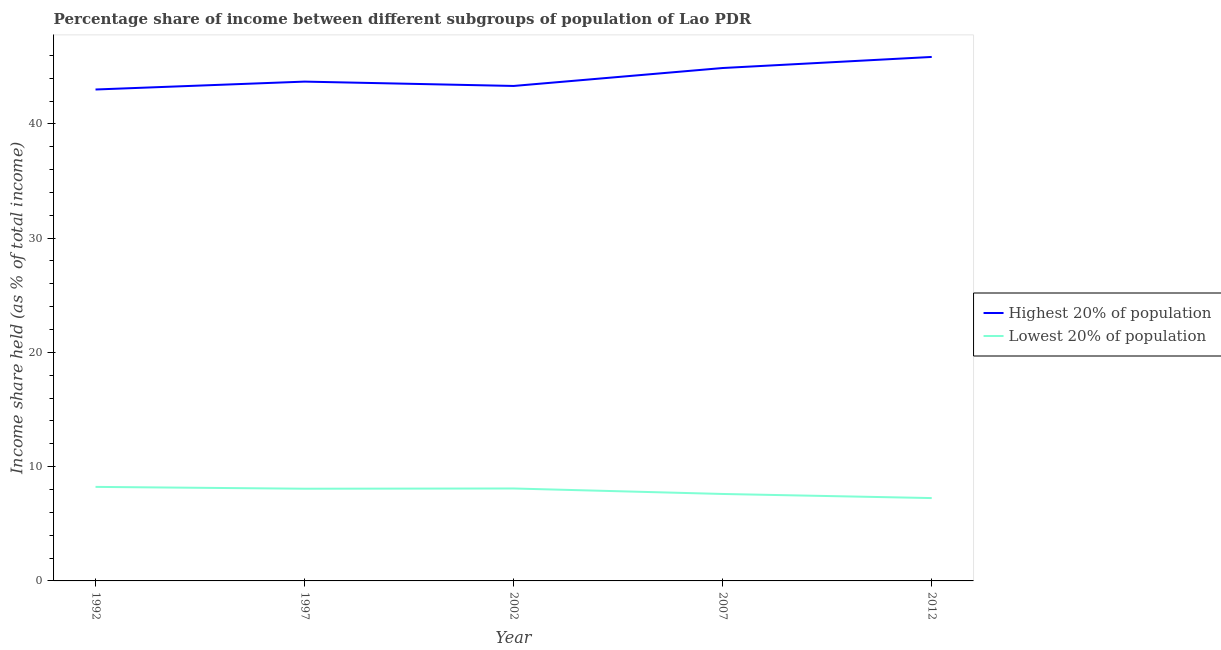How many different coloured lines are there?
Your answer should be compact. 2. What is the income share held by lowest 20% of the population in 2007?
Your response must be concise. 7.61. Across all years, what is the maximum income share held by highest 20% of the population?
Ensure brevity in your answer.  45.86. Across all years, what is the minimum income share held by highest 20% of the population?
Your answer should be compact. 43.01. In which year was the income share held by lowest 20% of the population maximum?
Your answer should be very brief. 1992. In which year was the income share held by highest 20% of the population minimum?
Provide a short and direct response. 1992. What is the total income share held by highest 20% of the population in the graph?
Offer a very short reply. 220.78. What is the difference between the income share held by lowest 20% of the population in 2002 and that in 2007?
Your response must be concise. 0.48. What is the difference between the income share held by highest 20% of the population in 2012 and the income share held by lowest 20% of the population in 1992?
Provide a short and direct response. 37.63. What is the average income share held by lowest 20% of the population per year?
Provide a succinct answer. 7.85. In the year 2007, what is the difference between the income share held by lowest 20% of the population and income share held by highest 20% of the population?
Your response must be concise. -37.28. What is the ratio of the income share held by lowest 20% of the population in 1997 to that in 2012?
Ensure brevity in your answer.  1.11. What is the difference between the highest and the second highest income share held by highest 20% of the population?
Your answer should be very brief. 0.97. What is the difference between the highest and the lowest income share held by highest 20% of the population?
Your response must be concise. 2.85. Is the sum of the income share held by lowest 20% of the population in 2007 and 2012 greater than the maximum income share held by highest 20% of the population across all years?
Ensure brevity in your answer.  No. Does the income share held by lowest 20% of the population monotonically increase over the years?
Your answer should be very brief. No. Is the income share held by lowest 20% of the population strictly greater than the income share held by highest 20% of the population over the years?
Provide a succinct answer. No. How many years are there in the graph?
Ensure brevity in your answer.  5. What is the difference between two consecutive major ticks on the Y-axis?
Your answer should be compact. 10. Are the values on the major ticks of Y-axis written in scientific E-notation?
Ensure brevity in your answer.  No. Does the graph contain any zero values?
Your answer should be very brief. No. Does the graph contain grids?
Ensure brevity in your answer.  No. Where does the legend appear in the graph?
Provide a short and direct response. Center right. How many legend labels are there?
Your response must be concise. 2. How are the legend labels stacked?
Your answer should be compact. Vertical. What is the title of the graph?
Provide a succinct answer. Percentage share of income between different subgroups of population of Lao PDR. What is the label or title of the Y-axis?
Your response must be concise. Income share held (as % of total income). What is the Income share held (as % of total income) in Highest 20% of population in 1992?
Your response must be concise. 43.01. What is the Income share held (as % of total income) of Lowest 20% of population in 1992?
Offer a very short reply. 8.23. What is the Income share held (as % of total income) in Highest 20% of population in 1997?
Offer a very short reply. 43.7. What is the Income share held (as % of total income) in Lowest 20% of population in 1997?
Make the answer very short. 8.07. What is the Income share held (as % of total income) of Highest 20% of population in 2002?
Make the answer very short. 43.32. What is the Income share held (as % of total income) of Lowest 20% of population in 2002?
Your answer should be compact. 8.09. What is the Income share held (as % of total income) in Highest 20% of population in 2007?
Provide a succinct answer. 44.89. What is the Income share held (as % of total income) in Lowest 20% of population in 2007?
Your response must be concise. 7.61. What is the Income share held (as % of total income) in Highest 20% of population in 2012?
Offer a terse response. 45.86. What is the Income share held (as % of total income) in Lowest 20% of population in 2012?
Offer a very short reply. 7.25. Across all years, what is the maximum Income share held (as % of total income) in Highest 20% of population?
Give a very brief answer. 45.86. Across all years, what is the maximum Income share held (as % of total income) in Lowest 20% of population?
Your response must be concise. 8.23. Across all years, what is the minimum Income share held (as % of total income) of Highest 20% of population?
Offer a terse response. 43.01. Across all years, what is the minimum Income share held (as % of total income) in Lowest 20% of population?
Provide a succinct answer. 7.25. What is the total Income share held (as % of total income) of Highest 20% of population in the graph?
Offer a terse response. 220.78. What is the total Income share held (as % of total income) in Lowest 20% of population in the graph?
Provide a succinct answer. 39.25. What is the difference between the Income share held (as % of total income) in Highest 20% of population in 1992 and that in 1997?
Provide a short and direct response. -0.69. What is the difference between the Income share held (as % of total income) in Lowest 20% of population in 1992 and that in 1997?
Offer a very short reply. 0.16. What is the difference between the Income share held (as % of total income) of Highest 20% of population in 1992 and that in 2002?
Your answer should be compact. -0.31. What is the difference between the Income share held (as % of total income) of Lowest 20% of population in 1992 and that in 2002?
Offer a very short reply. 0.14. What is the difference between the Income share held (as % of total income) of Highest 20% of population in 1992 and that in 2007?
Offer a very short reply. -1.88. What is the difference between the Income share held (as % of total income) in Lowest 20% of population in 1992 and that in 2007?
Provide a succinct answer. 0.62. What is the difference between the Income share held (as % of total income) in Highest 20% of population in 1992 and that in 2012?
Give a very brief answer. -2.85. What is the difference between the Income share held (as % of total income) of Lowest 20% of population in 1992 and that in 2012?
Make the answer very short. 0.98. What is the difference between the Income share held (as % of total income) of Highest 20% of population in 1997 and that in 2002?
Ensure brevity in your answer.  0.38. What is the difference between the Income share held (as % of total income) of Lowest 20% of population in 1997 and that in 2002?
Provide a short and direct response. -0.02. What is the difference between the Income share held (as % of total income) in Highest 20% of population in 1997 and that in 2007?
Give a very brief answer. -1.19. What is the difference between the Income share held (as % of total income) of Lowest 20% of population in 1997 and that in 2007?
Your response must be concise. 0.46. What is the difference between the Income share held (as % of total income) of Highest 20% of population in 1997 and that in 2012?
Your response must be concise. -2.16. What is the difference between the Income share held (as % of total income) of Lowest 20% of population in 1997 and that in 2012?
Give a very brief answer. 0.82. What is the difference between the Income share held (as % of total income) of Highest 20% of population in 2002 and that in 2007?
Offer a very short reply. -1.57. What is the difference between the Income share held (as % of total income) of Lowest 20% of population in 2002 and that in 2007?
Offer a very short reply. 0.48. What is the difference between the Income share held (as % of total income) of Highest 20% of population in 2002 and that in 2012?
Your answer should be compact. -2.54. What is the difference between the Income share held (as % of total income) of Lowest 20% of population in 2002 and that in 2012?
Keep it short and to the point. 0.84. What is the difference between the Income share held (as % of total income) of Highest 20% of population in 2007 and that in 2012?
Make the answer very short. -0.97. What is the difference between the Income share held (as % of total income) of Lowest 20% of population in 2007 and that in 2012?
Provide a short and direct response. 0.36. What is the difference between the Income share held (as % of total income) in Highest 20% of population in 1992 and the Income share held (as % of total income) in Lowest 20% of population in 1997?
Your answer should be compact. 34.94. What is the difference between the Income share held (as % of total income) in Highest 20% of population in 1992 and the Income share held (as % of total income) in Lowest 20% of population in 2002?
Provide a short and direct response. 34.92. What is the difference between the Income share held (as % of total income) of Highest 20% of population in 1992 and the Income share held (as % of total income) of Lowest 20% of population in 2007?
Offer a terse response. 35.4. What is the difference between the Income share held (as % of total income) in Highest 20% of population in 1992 and the Income share held (as % of total income) in Lowest 20% of population in 2012?
Provide a short and direct response. 35.76. What is the difference between the Income share held (as % of total income) of Highest 20% of population in 1997 and the Income share held (as % of total income) of Lowest 20% of population in 2002?
Give a very brief answer. 35.61. What is the difference between the Income share held (as % of total income) of Highest 20% of population in 1997 and the Income share held (as % of total income) of Lowest 20% of population in 2007?
Your response must be concise. 36.09. What is the difference between the Income share held (as % of total income) of Highest 20% of population in 1997 and the Income share held (as % of total income) of Lowest 20% of population in 2012?
Keep it short and to the point. 36.45. What is the difference between the Income share held (as % of total income) in Highest 20% of population in 2002 and the Income share held (as % of total income) in Lowest 20% of population in 2007?
Give a very brief answer. 35.71. What is the difference between the Income share held (as % of total income) of Highest 20% of population in 2002 and the Income share held (as % of total income) of Lowest 20% of population in 2012?
Offer a terse response. 36.07. What is the difference between the Income share held (as % of total income) of Highest 20% of population in 2007 and the Income share held (as % of total income) of Lowest 20% of population in 2012?
Offer a terse response. 37.64. What is the average Income share held (as % of total income) in Highest 20% of population per year?
Give a very brief answer. 44.16. What is the average Income share held (as % of total income) in Lowest 20% of population per year?
Your answer should be compact. 7.85. In the year 1992, what is the difference between the Income share held (as % of total income) in Highest 20% of population and Income share held (as % of total income) in Lowest 20% of population?
Offer a very short reply. 34.78. In the year 1997, what is the difference between the Income share held (as % of total income) of Highest 20% of population and Income share held (as % of total income) of Lowest 20% of population?
Provide a succinct answer. 35.63. In the year 2002, what is the difference between the Income share held (as % of total income) in Highest 20% of population and Income share held (as % of total income) in Lowest 20% of population?
Give a very brief answer. 35.23. In the year 2007, what is the difference between the Income share held (as % of total income) of Highest 20% of population and Income share held (as % of total income) of Lowest 20% of population?
Make the answer very short. 37.28. In the year 2012, what is the difference between the Income share held (as % of total income) in Highest 20% of population and Income share held (as % of total income) in Lowest 20% of population?
Offer a terse response. 38.61. What is the ratio of the Income share held (as % of total income) in Highest 20% of population in 1992 to that in 1997?
Give a very brief answer. 0.98. What is the ratio of the Income share held (as % of total income) of Lowest 20% of population in 1992 to that in 1997?
Offer a very short reply. 1.02. What is the ratio of the Income share held (as % of total income) of Highest 20% of population in 1992 to that in 2002?
Provide a succinct answer. 0.99. What is the ratio of the Income share held (as % of total income) of Lowest 20% of population in 1992 to that in 2002?
Your answer should be compact. 1.02. What is the ratio of the Income share held (as % of total income) of Highest 20% of population in 1992 to that in 2007?
Keep it short and to the point. 0.96. What is the ratio of the Income share held (as % of total income) in Lowest 20% of population in 1992 to that in 2007?
Your answer should be compact. 1.08. What is the ratio of the Income share held (as % of total income) of Highest 20% of population in 1992 to that in 2012?
Make the answer very short. 0.94. What is the ratio of the Income share held (as % of total income) of Lowest 20% of population in 1992 to that in 2012?
Provide a succinct answer. 1.14. What is the ratio of the Income share held (as % of total income) of Highest 20% of population in 1997 to that in 2002?
Provide a succinct answer. 1.01. What is the ratio of the Income share held (as % of total income) of Lowest 20% of population in 1997 to that in 2002?
Offer a very short reply. 1. What is the ratio of the Income share held (as % of total income) of Highest 20% of population in 1997 to that in 2007?
Provide a succinct answer. 0.97. What is the ratio of the Income share held (as % of total income) of Lowest 20% of population in 1997 to that in 2007?
Offer a terse response. 1.06. What is the ratio of the Income share held (as % of total income) in Highest 20% of population in 1997 to that in 2012?
Keep it short and to the point. 0.95. What is the ratio of the Income share held (as % of total income) in Lowest 20% of population in 1997 to that in 2012?
Your answer should be compact. 1.11. What is the ratio of the Income share held (as % of total income) of Lowest 20% of population in 2002 to that in 2007?
Provide a short and direct response. 1.06. What is the ratio of the Income share held (as % of total income) of Highest 20% of population in 2002 to that in 2012?
Offer a terse response. 0.94. What is the ratio of the Income share held (as % of total income) of Lowest 20% of population in 2002 to that in 2012?
Make the answer very short. 1.12. What is the ratio of the Income share held (as % of total income) of Highest 20% of population in 2007 to that in 2012?
Your response must be concise. 0.98. What is the ratio of the Income share held (as % of total income) of Lowest 20% of population in 2007 to that in 2012?
Make the answer very short. 1.05. What is the difference between the highest and the second highest Income share held (as % of total income) of Lowest 20% of population?
Make the answer very short. 0.14. What is the difference between the highest and the lowest Income share held (as % of total income) in Highest 20% of population?
Your answer should be compact. 2.85. What is the difference between the highest and the lowest Income share held (as % of total income) in Lowest 20% of population?
Your answer should be compact. 0.98. 